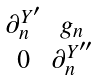Convert formula to latex. <formula><loc_0><loc_0><loc_500><loc_500>\begin{smallmatrix} \partial ^ { Y ^ { \prime } } _ { n } & g _ { n } \\ 0 & \partial ^ { Y ^ { \prime \prime } } _ { n } \end{smallmatrix}</formula> 